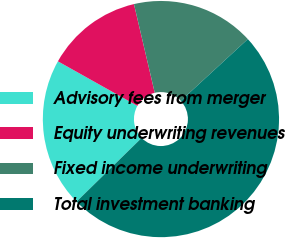Convert chart to OTSL. <chart><loc_0><loc_0><loc_500><loc_500><pie_chart><fcel>Advisory fees from merger<fcel>Equity underwriting revenues<fcel>Fixed income underwriting<fcel>Total investment banking<nl><fcel>20.46%<fcel>13.2%<fcel>16.83%<fcel>49.51%<nl></chart> 